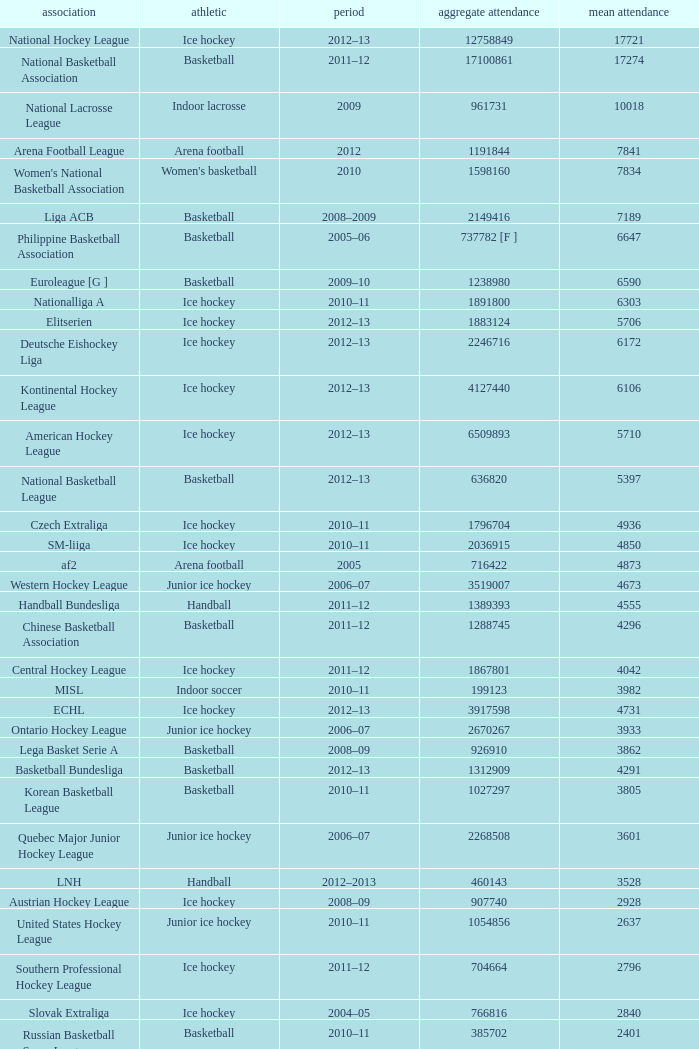What was the peak average attendance in the 2009 season? 10018.0. Would you mind parsing the complete table? {'header': ['association', 'athletic', 'period', 'aggregate attendance', 'mean attendance'], 'rows': [['National Hockey League', 'Ice hockey', '2012–13', '12758849', '17721'], ['National Basketball Association', 'Basketball', '2011–12', '17100861', '17274'], ['National Lacrosse League', 'Indoor lacrosse', '2009', '961731', '10018'], ['Arena Football League', 'Arena football', '2012', '1191844', '7841'], ["Women's National Basketball Association", "Women's basketball", '2010', '1598160', '7834'], ['Liga ACB', 'Basketball', '2008–2009', '2149416', '7189'], ['Philippine Basketball Association', 'Basketball', '2005–06', '737782 [F ]', '6647'], ['Euroleague [G ]', 'Basketball', '2009–10', '1238980', '6590'], ['Nationalliga A', 'Ice hockey', '2010–11', '1891800', '6303'], ['Elitserien', 'Ice hockey', '2012–13', '1883124', '5706'], ['Deutsche Eishockey Liga', 'Ice hockey', '2012–13', '2246716', '6172'], ['Kontinental Hockey League', 'Ice hockey', '2012–13', '4127440', '6106'], ['American Hockey League', 'Ice hockey', '2012–13', '6509893', '5710'], ['National Basketball League', 'Basketball', '2012–13', '636820', '5397'], ['Czech Extraliga', 'Ice hockey', '2010–11', '1796704', '4936'], ['SM-liiga', 'Ice hockey', '2010–11', '2036915', '4850'], ['af2', 'Arena football', '2005', '716422', '4873'], ['Western Hockey League', 'Junior ice hockey', '2006–07', '3519007', '4673'], ['Handball Bundesliga', 'Handball', '2011–12', '1389393', '4555'], ['Chinese Basketball Association', 'Basketball', '2011–12', '1288745', '4296'], ['Central Hockey League', 'Ice hockey', '2011–12', '1867801', '4042'], ['MISL', 'Indoor soccer', '2010–11', '199123', '3982'], ['ECHL', 'Ice hockey', '2012–13', '3917598', '4731'], ['Ontario Hockey League', 'Junior ice hockey', '2006–07', '2670267', '3933'], ['Lega Basket Serie A', 'Basketball', '2008–09', '926910', '3862'], ['Basketball Bundesliga', 'Basketball', '2012–13', '1312909', '4291'], ['Korean Basketball League', 'Basketball', '2010–11', '1027297', '3805'], ['Quebec Major Junior Hockey League', 'Junior ice hockey', '2006–07', '2268508', '3601'], ['LNH', 'Handball', '2012–2013', '460143', '3528'], ['Austrian Hockey League', 'Ice hockey', '2008–09', '907740', '2928'], ['United States Hockey League', 'Junior ice hockey', '2010–11', '1054856', '2637'], ['Southern Professional Hockey League', 'Ice hockey', '2011–12', '704664', '2796'], ['Slovak Extraliga', 'Ice hockey', '2004–05', '766816', '2840'], ['Russian Basketball Super League', 'Basketball', '2010–11', '385702', '2401'], ['Lega Pallavolo Serie A', 'Volleyball', '2005–06', '469799', '2512'], ['HockeyAllsvenskan', 'Ice hockey', '2012–13', '1174766', '3227'], ['Elite Ice Hockey League', 'Ice Hockey', '2009–10', '743040', '2322'], ['Oddset Ligaen', 'Ice hockey', '2007–08', '407972', '1534'], ['UPC Ligaen', 'Ice hockey', '2005–06', '329768', '1335'], ['North American Hockey League', 'Junior ice hockey', '2010–11', '957323', '1269'], ['Pro A Volleyball', 'Volleyball', '2005–06', '213678', '1174'], ['Italian Rink Hockey League', 'Rink hockey', '2007–08', '115000', '632'], ['Minor Hockey League', 'Ice Hockey', '2012–13', '479003', '467'], ['Major Hockey League', 'Ice Hockey', '2012–13', '1356319', '1932'], ['VTB United League', 'Basketball', '2012–13', '572747', '2627'], ['Norwegian Premier League', "Women's handball", '2005–06', '58958', '447'], ['Polska Liga Koszykówki', 'Basketball', '2011–12', '535559', '1940']]} 